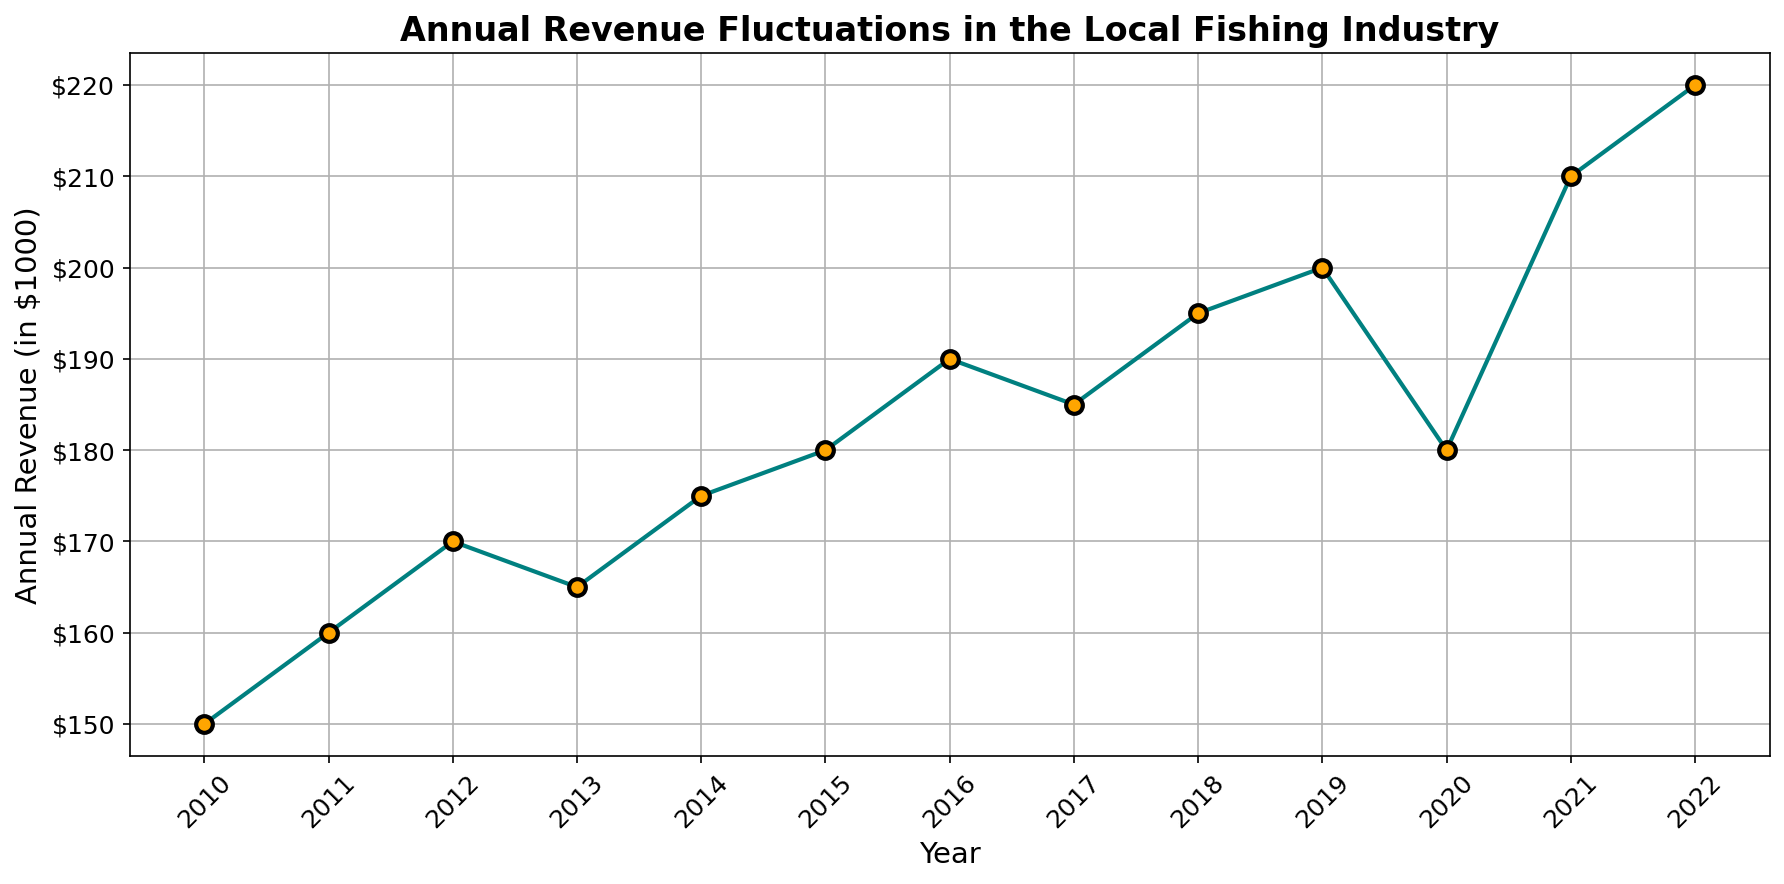How did the annual revenue change from 2011 to 2012? Observing the line graph, the revenue in 2011 was $160,000 and increased to $170,000 in 2012. So, the change is $170,000 - $160,000 = $10,000.
Answer: $10,000 In what year did the revenue first reach $200,000? Scanning the chart, the revenue first reaches $200,000 in 2019.
Answer: 2019 Which year had the highest revenue, and what was the value? Looking at the peak of the line graph, the highest revenue was in 2022 with a value of $220,000.
Answer: 2022, $220,000 Was the annual revenue in 2020 higher or lower than in 2019? Comparing the points on the graph for 2019 and 2020, the revenue in 2020 ($180,000) was lower than in 2019 ($200,000).
Answer: Lower What was the average annual revenue from 2010 to 2015? Summing the revenues for 2010 to 2015: $150,000 + $160,000 + $170,000 + $165,000 + $175,000 + $180,000, then dividing by 6 gives an average: (150 + 160 + 170 + 165 + 175 + 180)/6 = 1000/6 ≈ $166,667.
Answer: $166,667 Between 2016 and 2018, which year experienced the highest revenue and by how much? The revenues are $190,000 for 2016, $185,000 for 2017, and $195,000 for 2018. The highest is 2018 with $195,000, which is $5,000 more than 2016 ($190,000).
Answer: 2018, $5,000 What is the percentage increase in revenue from 2016 to 2022? Calculating the percentage increase: ((220,000 - 190,000) / 190,000) * 100 = (30,000 / 190,000) * 100 ≈ 15.79%.
Answer: 15.79% How did the revenue trend change in 2020, and what might this indicate? The chart shows a drop in revenue from $200,000 in 2019 to $180,000 in 2020, possibly indicating an adverse event or downturn affecting the industry.
Answer: Dropped, adverse event Which years saw revenue decreases compared to the previous year? Observing the chart, revenue decreases occurred from 2013 to 2014, 2017 to 2018, and 2019 to 2020.
Answer: 2013-2014, 2017-2018, 2019-2020 What is the overall trend in the fishing industry's revenue from 2010 to 2022? The general trend shown in the line graph is an upward trajectory, with some fluctuations, indicating growth over the period.
Answer: Upward 